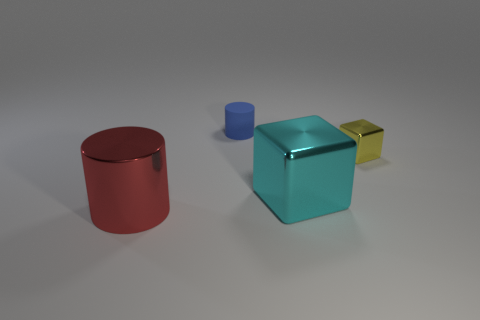Add 2 small rubber things. How many objects exist? 6 Subtract 1 blue cylinders. How many objects are left? 3 Subtract all matte objects. Subtract all metallic objects. How many objects are left? 0 Add 2 cyan metallic objects. How many cyan metallic objects are left? 3 Add 4 tiny cylinders. How many tiny cylinders exist? 5 